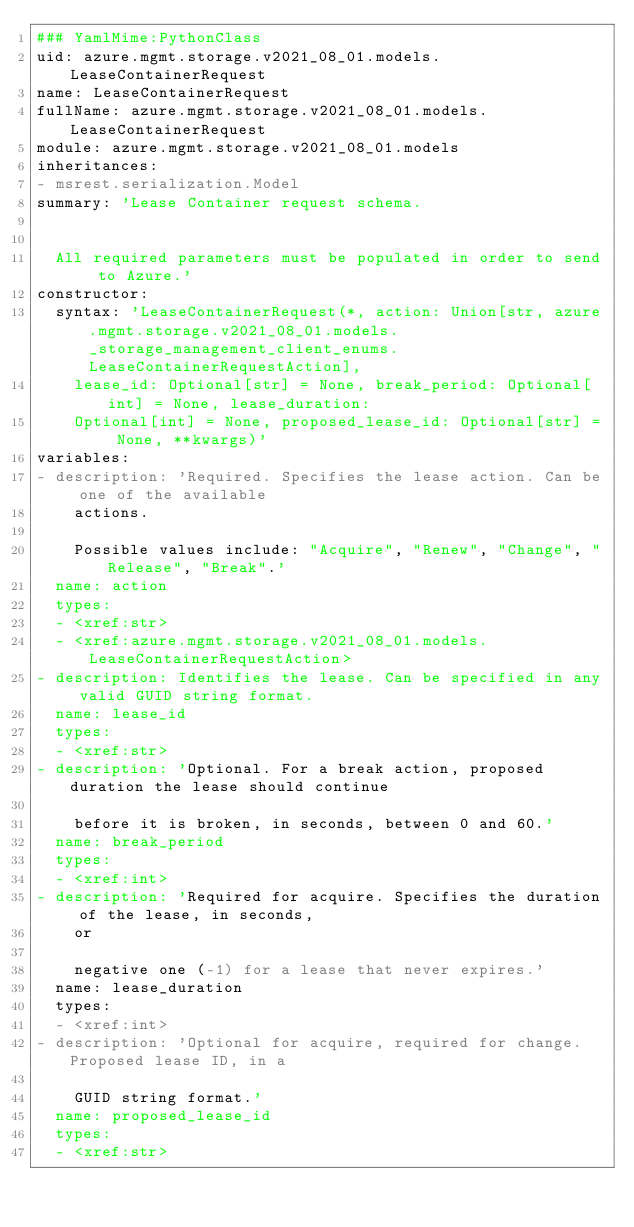Convert code to text. <code><loc_0><loc_0><loc_500><loc_500><_YAML_>### YamlMime:PythonClass
uid: azure.mgmt.storage.v2021_08_01.models.LeaseContainerRequest
name: LeaseContainerRequest
fullName: azure.mgmt.storage.v2021_08_01.models.LeaseContainerRequest
module: azure.mgmt.storage.v2021_08_01.models
inheritances:
- msrest.serialization.Model
summary: 'Lease Container request schema.


  All required parameters must be populated in order to send to Azure.'
constructor:
  syntax: 'LeaseContainerRequest(*, action: Union[str, azure.mgmt.storage.v2021_08_01.models._storage_management_client_enums.LeaseContainerRequestAction],
    lease_id: Optional[str] = None, break_period: Optional[int] = None, lease_duration:
    Optional[int] = None, proposed_lease_id: Optional[str] = None, **kwargs)'
variables:
- description: 'Required. Specifies the lease action. Can be one of the available
    actions.

    Possible values include: "Acquire", "Renew", "Change", "Release", "Break".'
  name: action
  types:
  - <xref:str>
  - <xref:azure.mgmt.storage.v2021_08_01.models.LeaseContainerRequestAction>
- description: Identifies the lease. Can be specified in any valid GUID string format.
  name: lease_id
  types:
  - <xref:str>
- description: 'Optional. For a break action, proposed duration the lease should continue

    before it is broken, in seconds, between 0 and 60.'
  name: break_period
  types:
  - <xref:int>
- description: 'Required for acquire. Specifies the duration of the lease, in seconds,
    or

    negative one (-1) for a lease that never expires.'
  name: lease_duration
  types:
  - <xref:int>
- description: 'Optional for acquire, required for change. Proposed lease ID, in a

    GUID string format.'
  name: proposed_lease_id
  types:
  - <xref:str>
</code> 